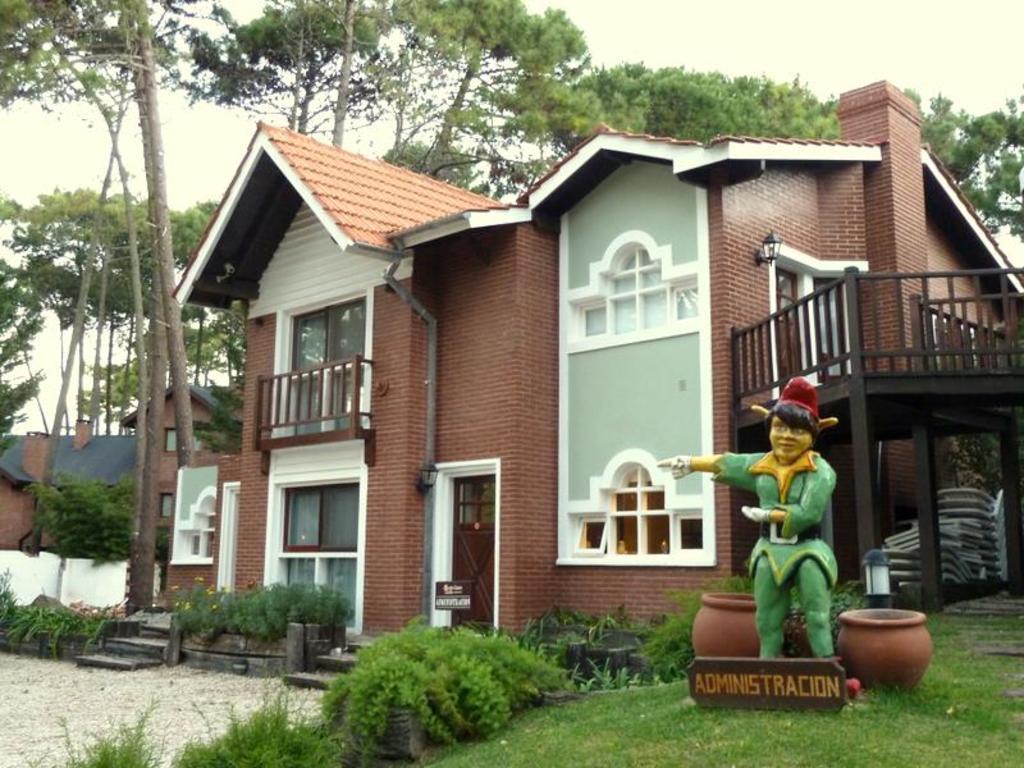How would you summarize this image in a sentence or two? In this image in the center there is grass on the ground and there is a board with some text written on it. There is a statue, there are pots, plants. In the background there are buildings, trees and the sky is cloudy. 